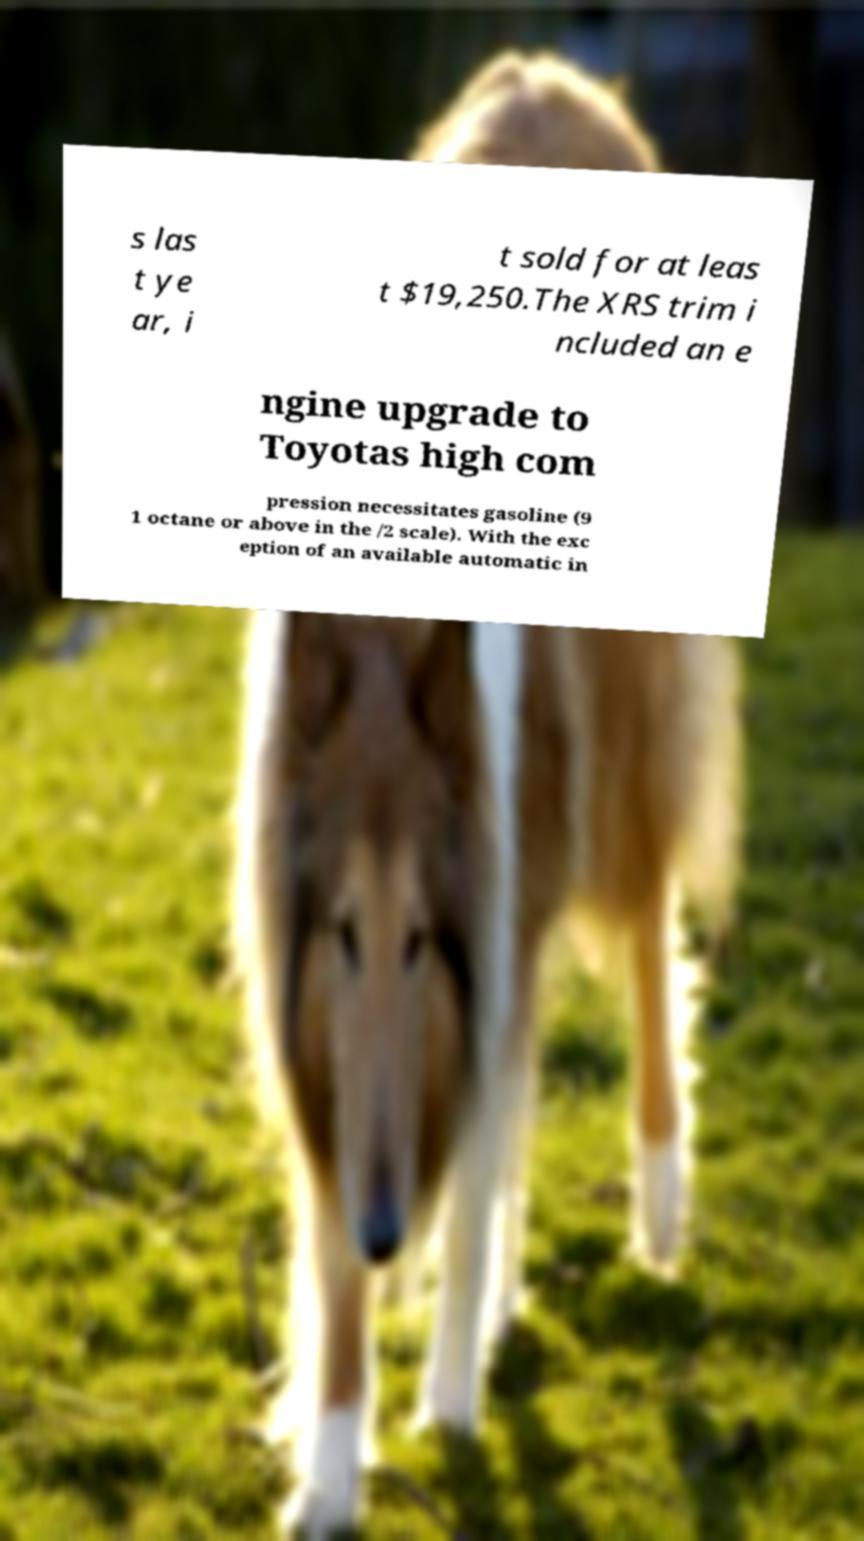I need the written content from this picture converted into text. Can you do that? s las t ye ar, i t sold for at leas t $19,250.The XRS trim i ncluded an e ngine upgrade to Toyotas high com pression necessitates gasoline (9 1 octane or above in the /2 scale). With the exc eption of an available automatic in 